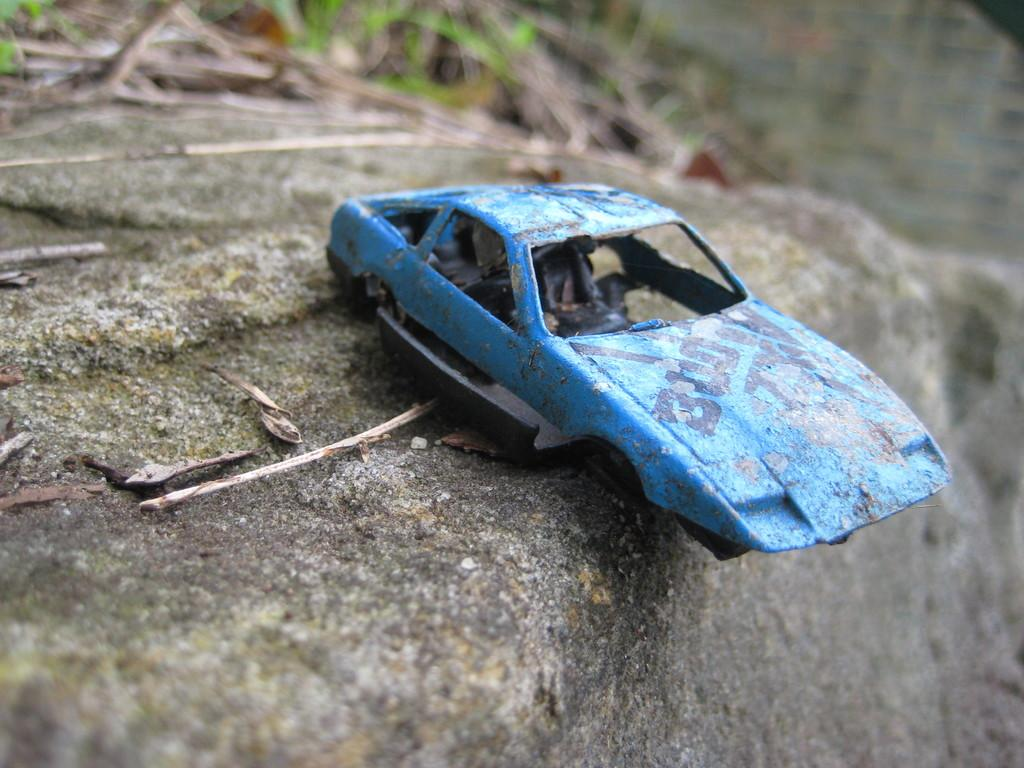What is the main object in the image? There is a toy car in the image. Where is the toy car located? The toy car is on a rock. What type of cap is the toy car wearing in the image? There is no cap present on the toy car in the image. 